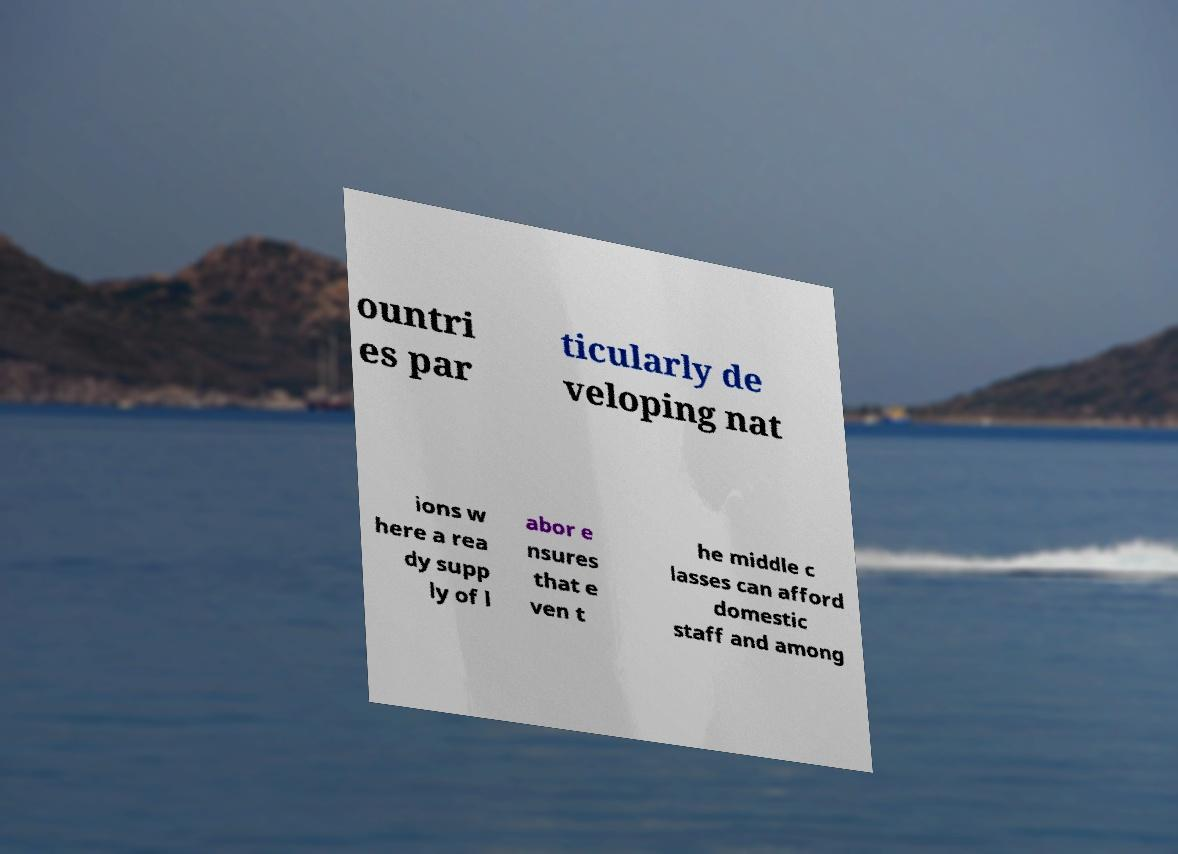There's text embedded in this image that I need extracted. Can you transcribe it verbatim? ountri es par ticularly de veloping nat ions w here a rea dy supp ly of l abor e nsures that e ven t he middle c lasses can afford domestic staff and among 